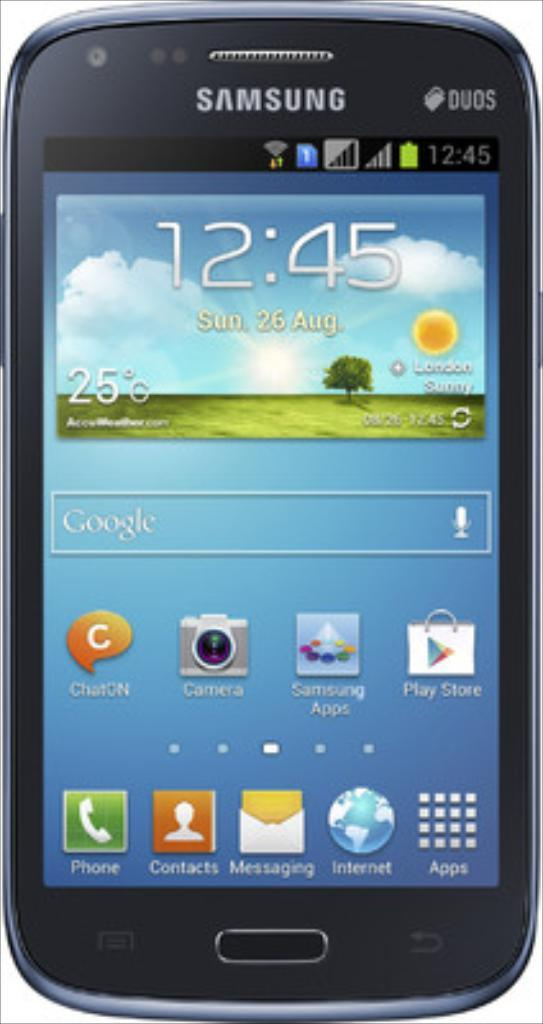<image>
Offer a succinct explanation of the picture presented. A Samsung Duos phone is turned on and at the home screen. 